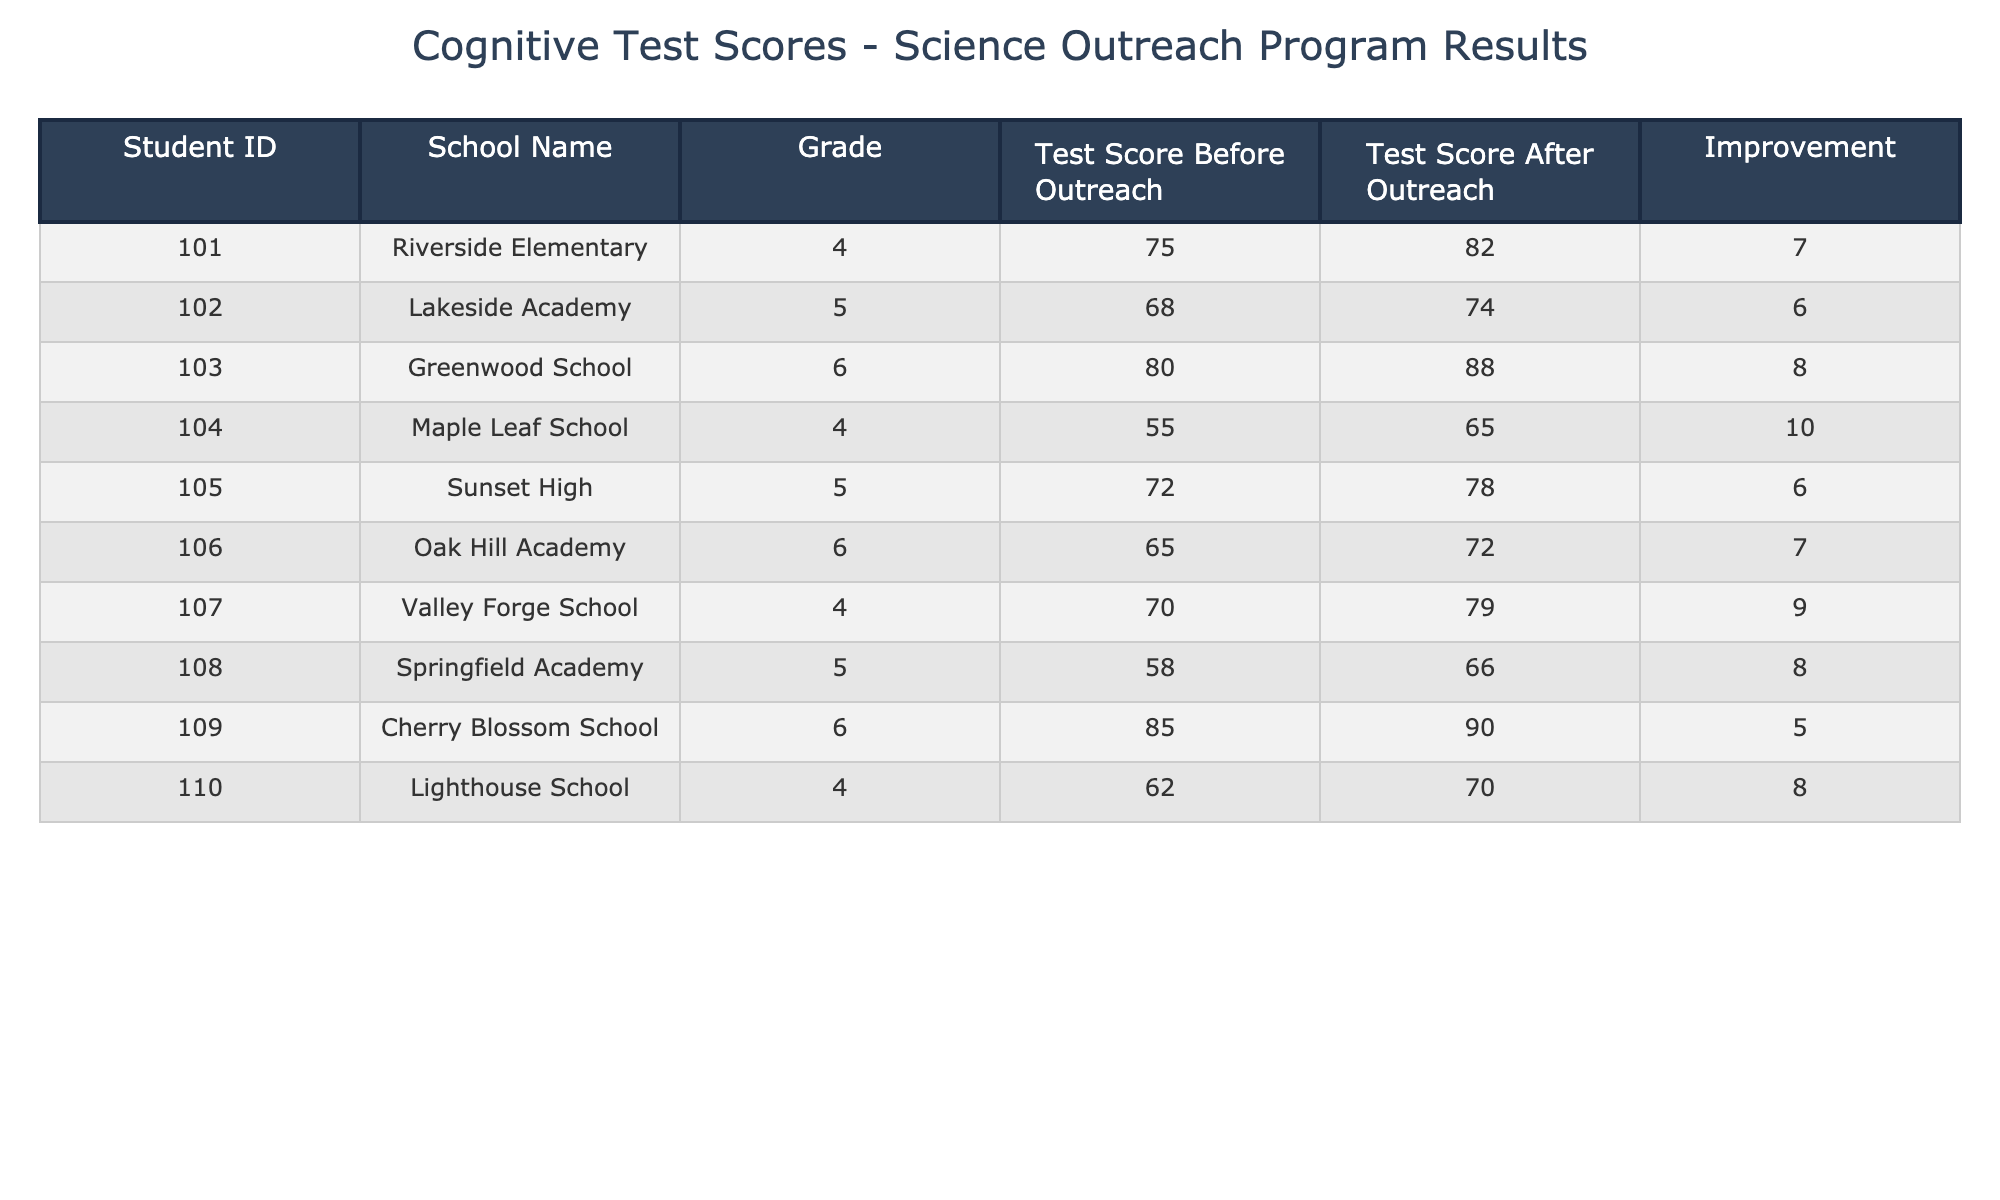What is the highest test score before the outreach program? By looking at the "Test Score Before Outreach" column, the highest score is 85 from student 109 at Cherry Blossom School.
Answer: 85 How many students improved their test scores by 8 points or more? By checking the "Improvement" column, the students with improvements of 8 or more are student 103 (+8), student 104 (+10), student 107 (+9), and student 108 (+8). There are a total of 4 students.
Answer: 4 What is the average test score after the outreach program? To find the average, sum all the "Test Score After Outreach" values (82 + 74 + 88 + 65 + 78 + 72 + 79 + 66 + 90 + 70 = 792) and divide by the number of students (10). The average is 792/10 = 79.2.
Answer: 79.2 Did all students score higher after the outreach program compared to before? By reviewing the "Test Score After Outreach" and "Test Score Before Outreach" columns, all after scores are higher than the before scores except for student 109, who improved but stayed the same. Thus, not all students scored higher, the answer is no.
Answer: No What is the improvement percentage for student 104 from Maple Leaf School? The improvement for student 104 is 10 points. To calculate the percentage improvement, use the formula (Improvement / Test Score Before Outreach) * 100, which is (10 / 55) * 100 = 18.18%.
Answer: 18.18% 